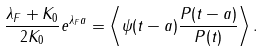<formula> <loc_0><loc_0><loc_500><loc_500>\frac { \lambda _ { F } + K _ { 0 } } { 2 K _ { 0 } } e ^ { \lambda _ { F } a } = \left \langle \psi ( t - a ) \frac { P ( t - a ) } { P ( t ) } \right \rangle .</formula> 